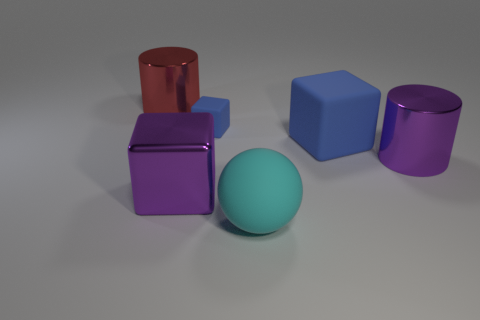What is the material of the large purple object that is the same shape as the small blue object?
Make the answer very short. Metal. There is a cyan thing that is the same size as the red metallic object; what material is it?
Offer a terse response. Rubber. How many big shiny cylinders are there?
Your answer should be very brief. 2. There is a rubber block on the left side of the cyan ball; what is its size?
Provide a short and direct response. Small. Are there the same number of red cylinders that are right of the tiny blue object and big purple cubes?
Your answer should be very brief. No. Are there any other big objects of the same shape as the red metallic object?
Provide a succinct answer. Yes. What is the shape of the matte object that is in front of the tiny blue matte thing and behind the cyan sphere?
Give a very brief answer. Cube. Does the big blue object have the same material as the blue cube on the left side of the large cyan matte object?
Offer a very short reply. Yes. There is a red metal cylinder; are there any big cyan rubber objects in front of it?
Ensure brevity in your answer.  Yes. How many objects are either purple shiny cubes or purple shiny objects that are in front of the big purple metal cylinder?
Give a very brief answer. 1. 